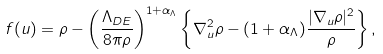Convert formula to latex. <formula><loc_0><loc_0><loc_500><loc_500>f ( { u } ) = \rho - \left ( \frac { \Lambda _ { D E } } { 8 \pi \rho } \right ) ^ { 1 + \alpha _ { \Lambda } } \left \{ \nabla _ { u } ^ { 2 } \rho - ( 1 + \alpha _ { \Lambda } ) \frac { | \nabla _ { u } \rho | ^ { 2 } } { \rho } \right \} ,</formula> 